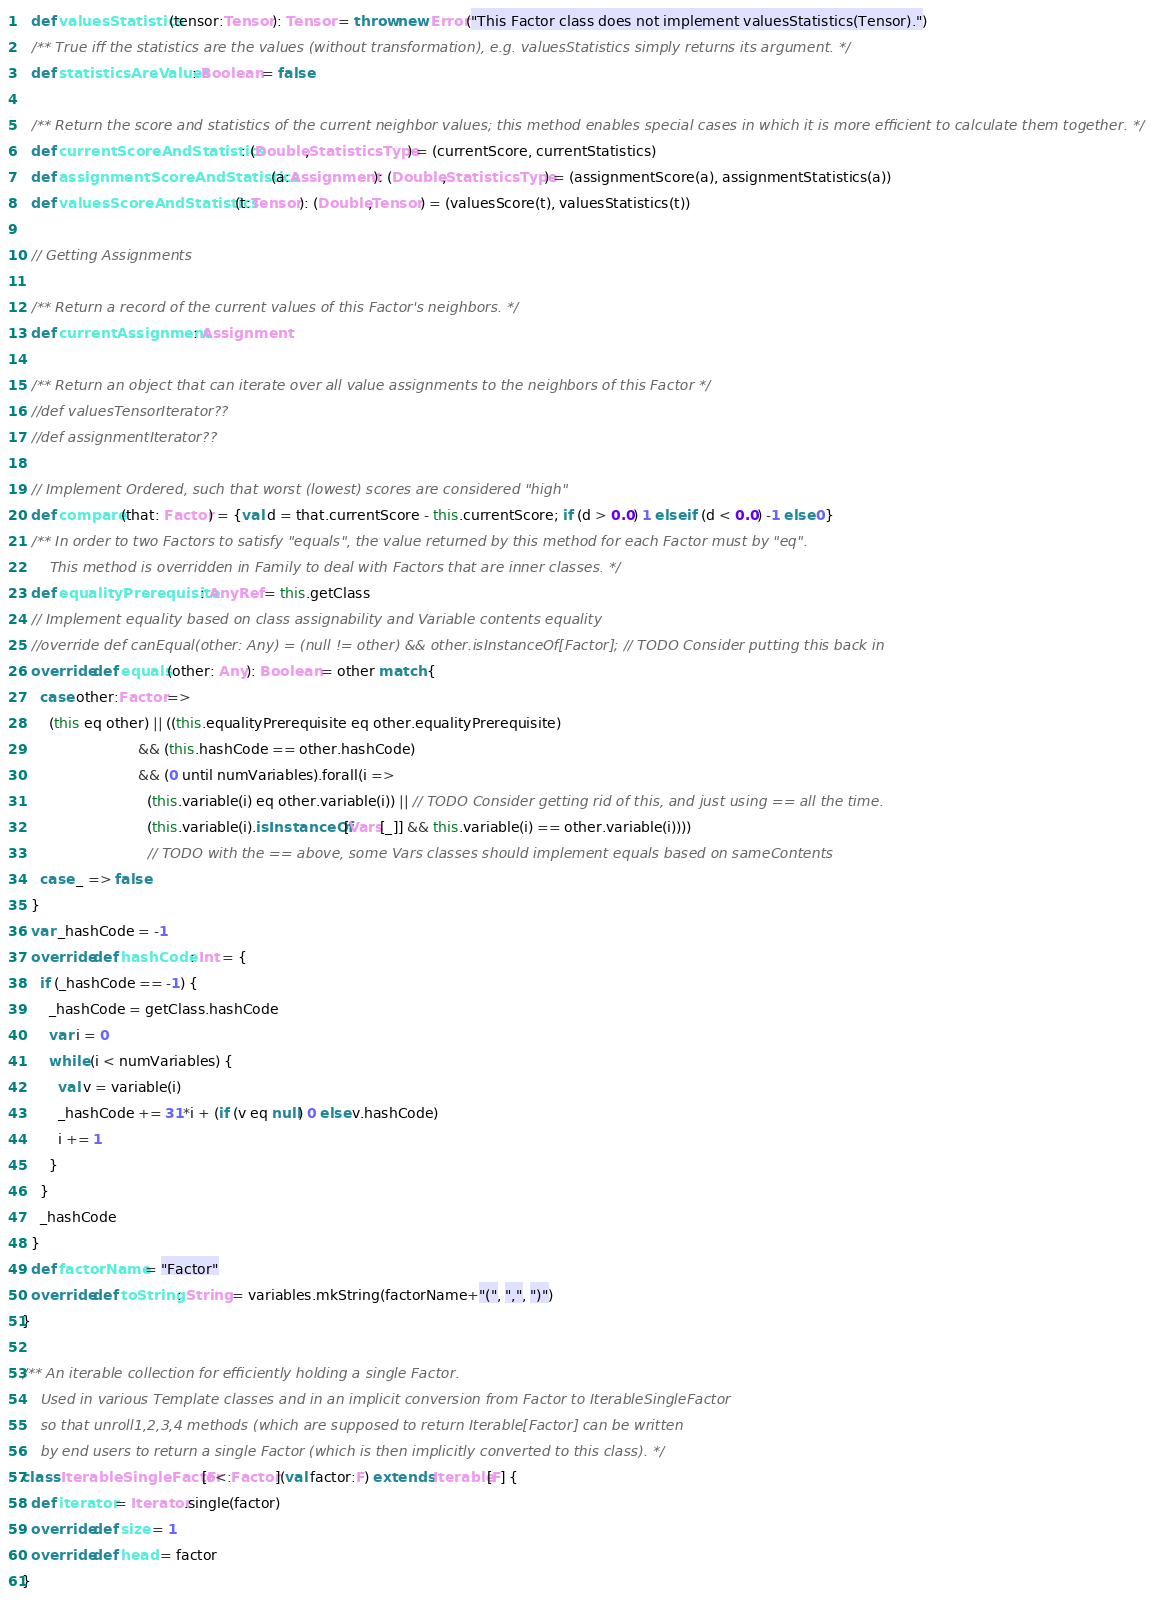Convert code to text. <code><loc_0><loc_0><loc_500><loc_500><_Scala_>  def valuesStatistics(tensor:Tensor): Tensor = throw new Error("This Factor class does not implement valuesStatistics(Tensor).")
  /** True iff the statistics are the values (without transformation), e.g. valuesStatistics simply returns its argument. */
  def statisticsAreValues: Boolean = false
  
  /** Return the score and statistics of the current neighbor values; this method enables special cases in which it is more efficient to calculate them together. */
  def currentScoreAndStatistics: (Double,StatisticsType) = (currentScore, currentStatistics)
  def assignmentScoreAndStatistics(a:Assignment): (Double,StatisticsType) = (assignmentScore(a), assignmentStatistics(a))
  def valuesScoreAndStatistics(t:Tensor): (Double,Tensor) = (valuesScore(t), valuesStatistics(t))

  // Getting Assignments

  /** Return a record of the current values of this Factor's neighbors. */
  def currentAssignment: Assignment

  /** Return an object that can iterate over all value assignments to the neighbors of this Factor */
  //def valuesTensorIterator??
  //def assignmentIterator??

  // Implement Ordered, such that worst (lowest) scores are considered "high"
  def compare(that: Factor) = {val d = that.currentScore - this.currentScore; if (d > 0.0) 1 else if (d < 0.0) -1 else 0}
  /** In order to two Factors to satisfy "equals", the value returned by this method for each Factor must by "eq".
      This method is overridden in Family to deal with Factors that are inner classes. */
  def equalityPrerequisite: AnyRef = this.getClass
  // Implement equality based on class assignability and Variable contents equality
  //override def canEqual(other: Any) = (null != other) && other.isInstanceOf[Factor]; // TODO Consider putting this back in
  override def equals(other: Any): Boolean = other match {
    case other:Factor =>
      (this eq other) || ((this.equalityPrerequisite eq other.equalityPrerequisite)
                          && (this.hashCode == other.hashCode)
                          && (0 until numVariables).forall(i =>
                            (this.variable(i) eq other.variable(i)) || // TODO Consider getting rid of this, and just using == all the time.
                            (this.variable(i).isInstanceOf[Vars[_]] && this.variable(i) == other.variable(i))))
                            // TODO with the == above, some Vars classes should implement equals based on sameContents
    case _ => false
  }
  var _hashCode = -1
  override def hashCode: Int = {
    if (_hashCode == -1) {
      _hashCode = getClass.hashCode
      var i = 0
      while (i < numVariables) {
        val v = variable(i)
        _hashCode += 31*i + (if (v eq null) 0 else v.hashCode)
        i += 1
      }
    }
    _hashCode
  }
  def factorName = "Factor"
  override def toString: String = variables.mkString(factorName+"(", ",", ")")
}

/** An iterable collection for efficiently holding a single Factor.
    Used in various Template classes and in an implicit conversion from Factor to IterableSingleFactor
    so that unroll1,2,3,4 methods (which are supposed to return Iterable[Factor] can be written
    by end users to return a single Factor (which is then implicitly converted to this class). */
class IterableSingleFactor[F<:Factor](val factor:F) extends Iterable[F] {
  def iterator = Iterator.single(factor)
  override def size = 1
  override def head = factor
}
</code> 